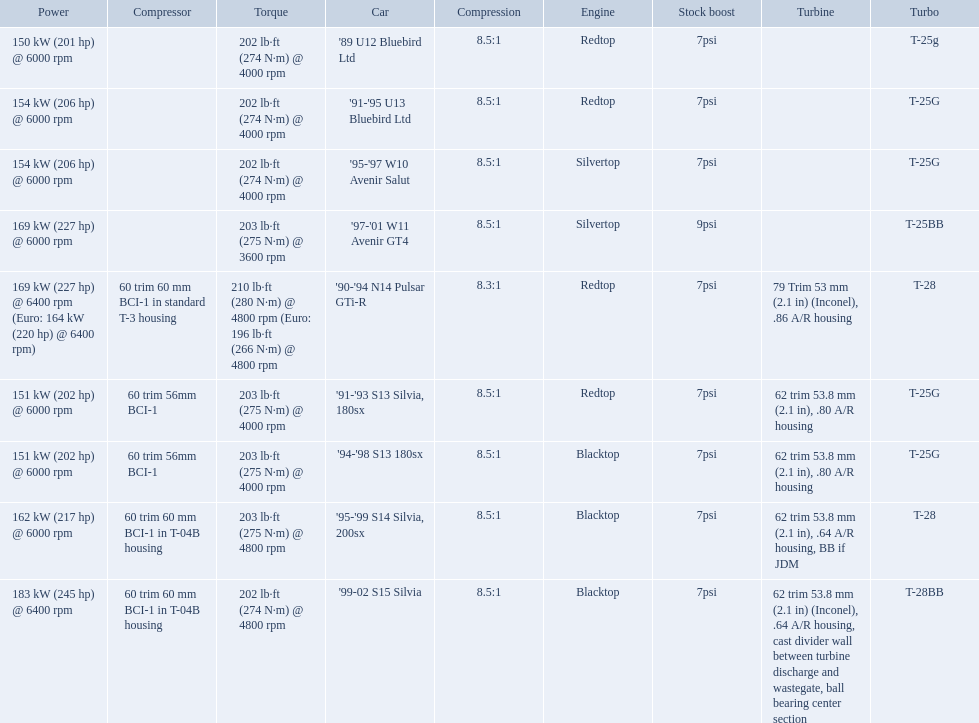What cars are there? '89 U12 Bluebird Ltd, 7psi, '91-'95 U13 Bluebird Ltd, 7psi, '95-'97 W10 Avenir Salut, 7psi, '97-'01 W11 Avenir GT4, 9psi, '90-'94 N14 Pulsar GTi-R, 7psi, '91-'93 S13 Silvia, 180sx, 7psi, '94-'98 S13 180sx, 7psi, '95-'99 S14 Silvia, 200sx, 7psi, '99-02 S15 Silvia, 7psi. Which stock boost is over 7psi? '97-'01 W11 Avenir GT4, 9psi. What car is it? '97-'01 W11 Avenir GT4. What are all of the cars? '89 U12 Bluebird Ltd, '91-'95 U13 Bluebird Ltd, '95-'97 W10 Avenir Salut, '97-'01 W11 Avenir GT4, '90-'94 N14 Pulsar GTi-R, '91-'93 S13 Silvia, 180sx, '94-'98 S13 180sx, '95-'99 S14 Silvia, 200sx, '99-02 S15 Silvia. What is their rated power? 150 kW (201 hp) @ 6000 rpm, 154 kW (206 hp) @ 6000 rpm, 154 kW (206 hp) @ 6000 rpm, 169 kW (227 hp) @ 6000 rpm, 169 kW (227 hp) @ 6400 rpm (Euro: 164 kW (220 hp) @ 6400 rpm), 151 kW (202 hp) @ 6000 rpm, 151 kW (202 hp) @ 6000 rpm, 162 kW (217 hp) @ 6000 rpm, 183 kW (245 hp) @ 6400 rpm. Which car has the most power? '99-02 S15 Silvia. 